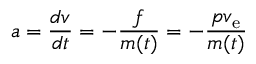<formula> <loc_0><loc_0><loc_500><loc_500>a = { \frac { d v } { d t } } = - { \frac { f } { m ( t ) } } = - { \frac { p v _ { e } } { m ( t ) } }</formula> 